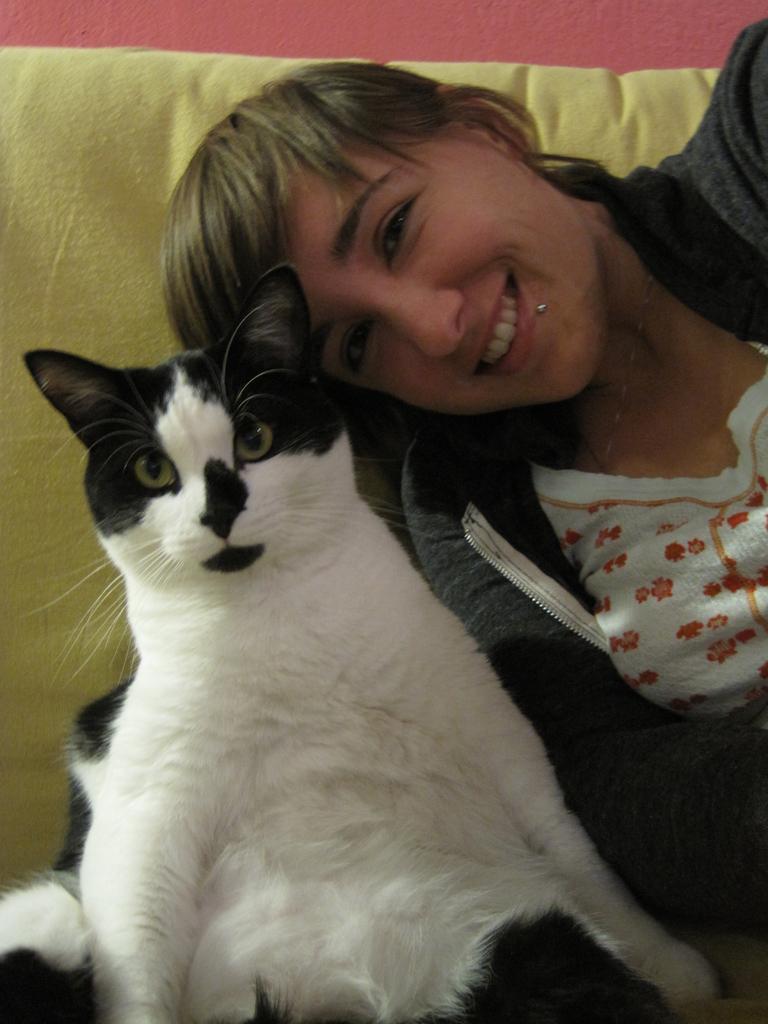Could you give a brief overview of what you see in this image? In this image i can see a woman and a cat sitting on a couch. 